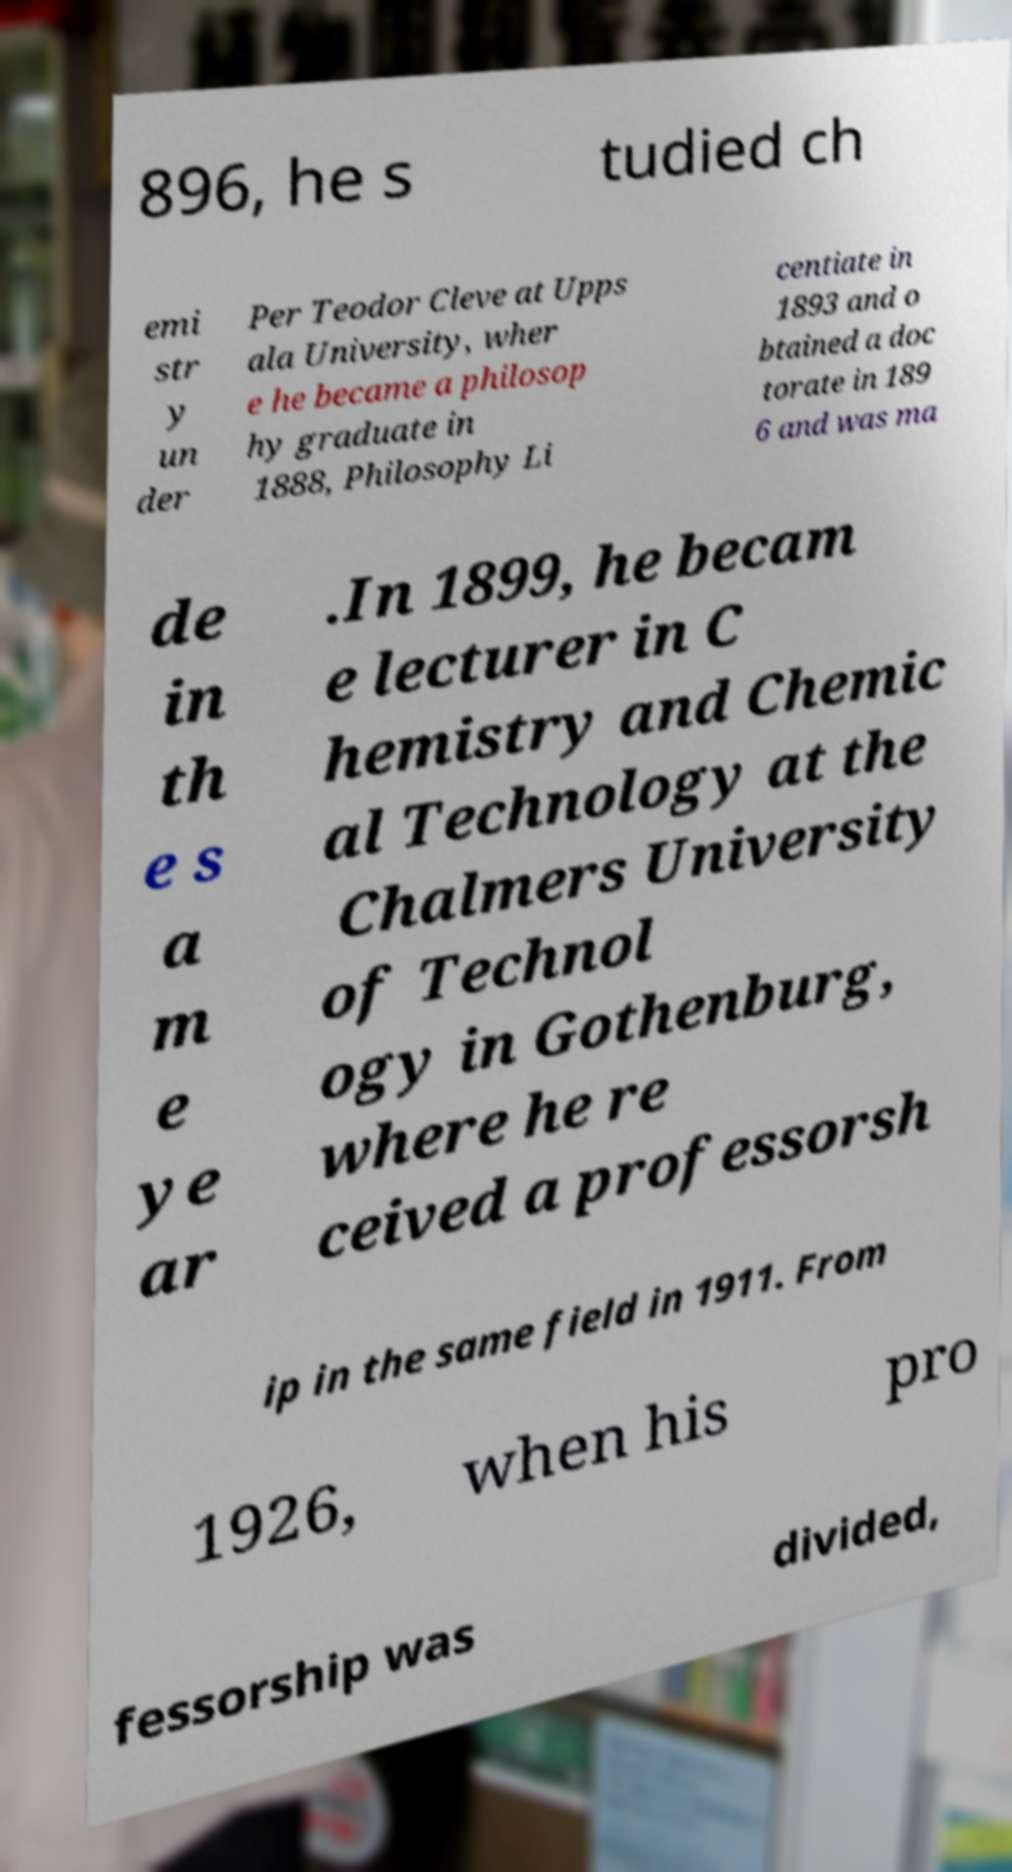Please identify and transcribe the text found in this image. 896, he s tudied ch emi str y un der Per Teodor Cleve at Upps ala University, wher e he became a philosop hy graduate in 1888, Philosophy Li centiate in 1893 and o btained a doc torate in 189 6 and was ma de in th e s a m e ye ar .In 1899, he becam e lecturer in C hemistry and Chemic al Technology at the Chalmers University of Technol ogy in Gothenburg, where he re ceived a professorsh ip in the same field in 1911. From 1926, when his pro fessorship was divided, 